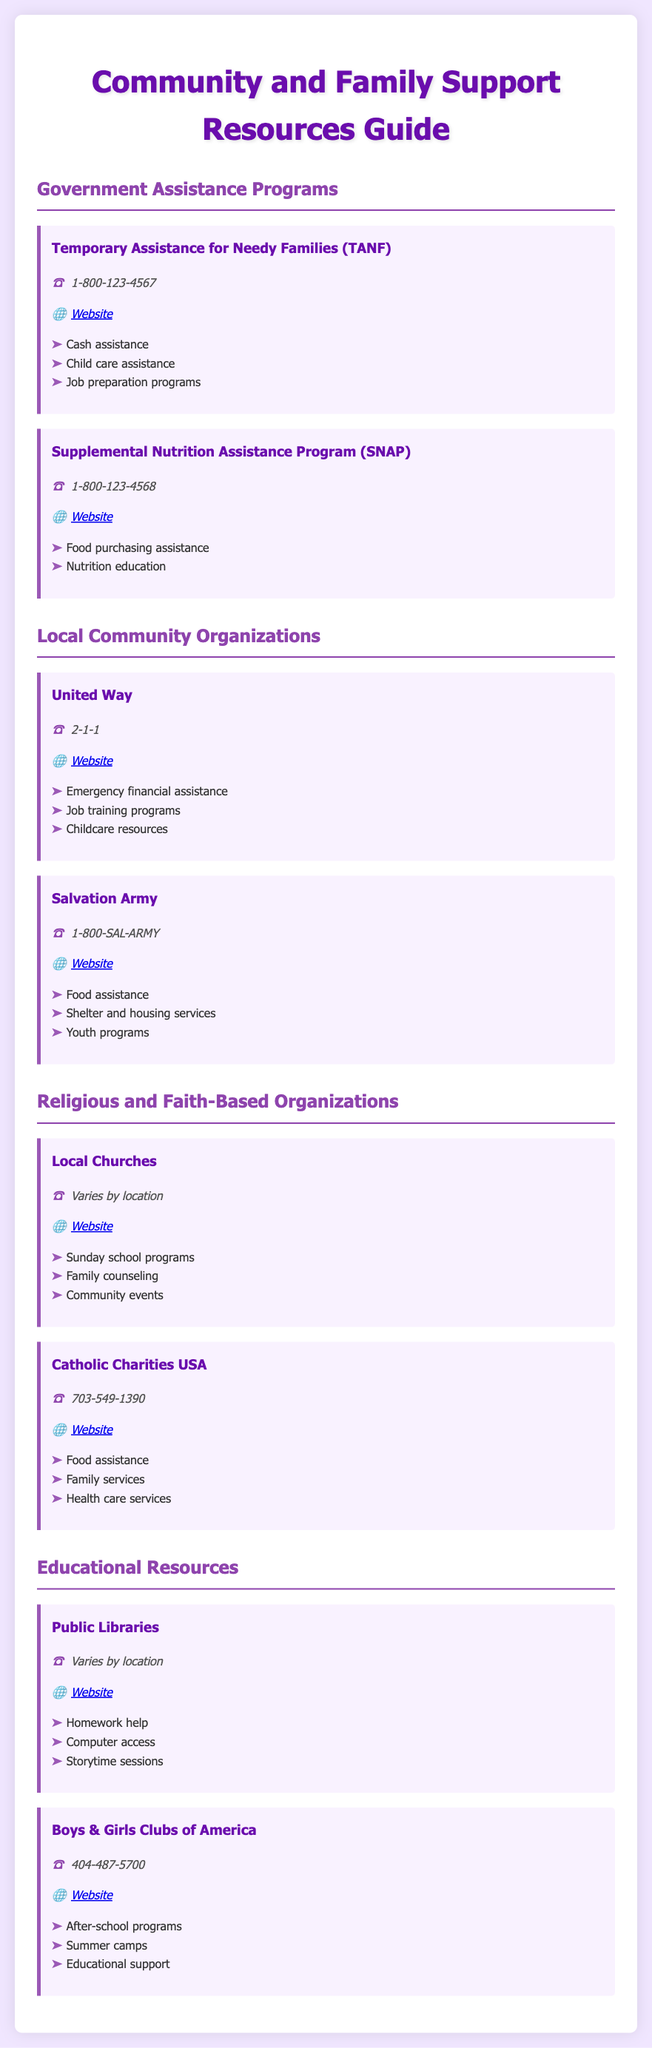What is the contact number for TANF? The contact number for TANF is listed as 1-800-123-4567.
Answer: 1-800-123-4567 What services does SNAP provide? SNAP provides food purchasing assistance and nutrition education.
Answer: Food purchasing assistance, nutrition education What is the website for United Way? The website for United Way is accessible via the provided link in the document.
Answer: www.unitedway.org Which organization offers youth programs? The Salvation Army is specifically mentioned as providing youth programs.
Answer: Salvation Army What is the contact number for Boys & Girls Clubs of America? The contact number listed is 404-487-5700.
Answer: 404-487-5700 What type of programs do local churches offer? Local churches offer Sunday school programs, family counseling, and community events.
Answer: Sunday school programs, family counseling, community events Which organization helps with emergency financial assistance? United Way is mentioned as providing emergency financial assistance.
Answer: United Way What type of assistance does Catholic Charities USA provide? Catholic Charities USA provides food assistance, family services, and health care services.
Answer: Food assistance, family services, health care services 